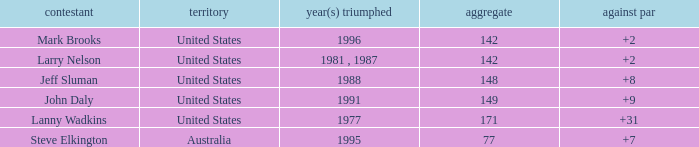Name the Total of jeff sluman? 148.0. 